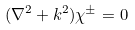Convert formula to latex. <formula><loc_0><loc_0><loc_500><loc_500>( \nabla ^ { 2 } + k ^ { 2 } ) \chi ^ { \pm } = 0</formula> 